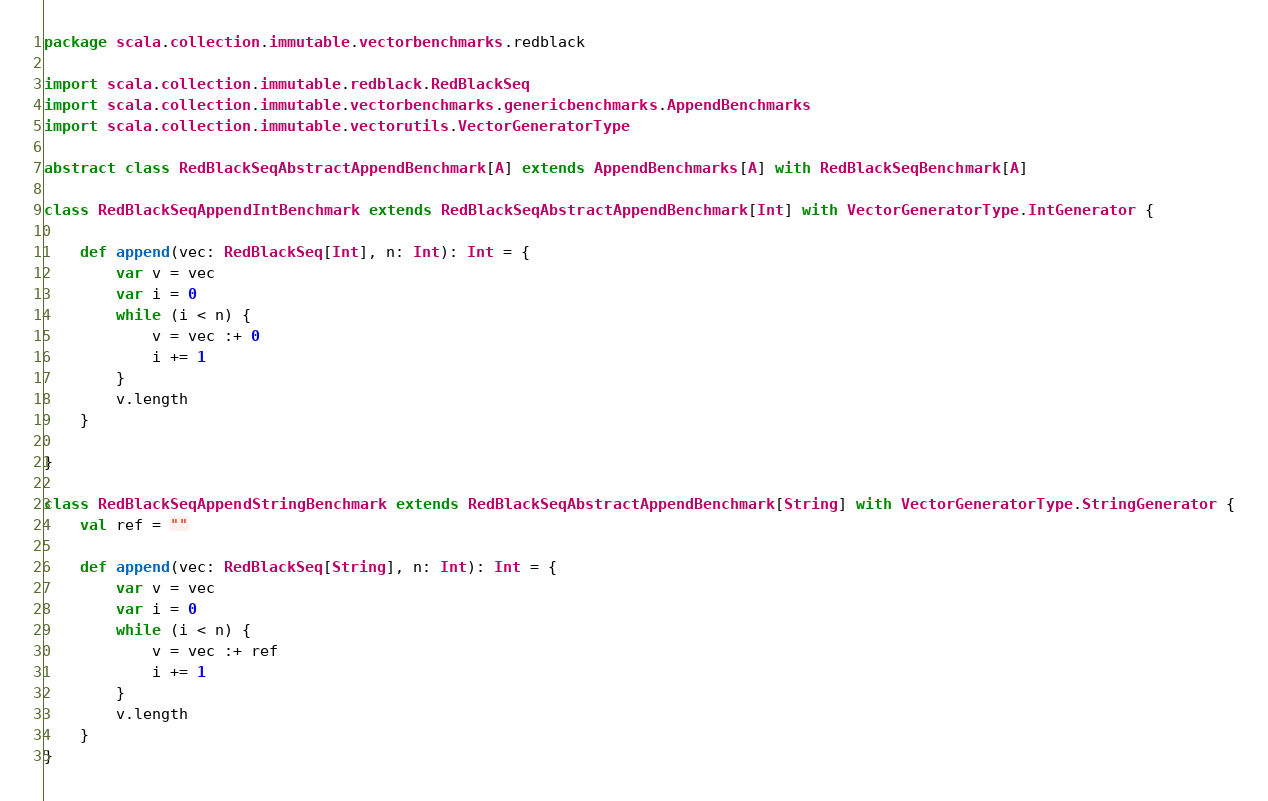Convert code to text. <code><loc_0><loc_0><loc_500><loc_500><_Scala_>package scala.collection.immutable.vectorbenchmarks.redblack

import scala.collection.immutable.redblack.RedBlackSeq
import scala.collection.immutable.vectorbenchmarks.genericbenchmarks.AppendBenchmarks
import scala.collection.immutable.vectorutils.VectorGeneratorType

abstract class RedBlackSeqAbstractAppendBenchmark[A] extends AppendBenchmarks[A] with RedBlackSeqBenchmark[A]

class RedBlackSeqAppendIntBenchmark extends RedBlackSeqAbstractAppendBenchmark[Int] with VectorGeneratorType.IntGenerator {

    def append(vec: RedBlackSeq[Int], n: Int): Int = {
        var v = vec
        var i = 0
        while (i < n) {
            v = vec :+ 0
            i += 1
        }
        v.length
    }

}

class RedBlackSeqAppendStringBenchmark extends RedBlackSeqAbstractAppendBenchmark[String] with VectorGeneratorType.StringGenerator {
    val ref = ""

    def append(vec: RedBlackSeq[String], n: Int): Int = {
        var v = vec
        var i = 0
        while (i < n) {
            v = vec :+ ref
            i += 1
        }
        v.length
    }
}</code> 